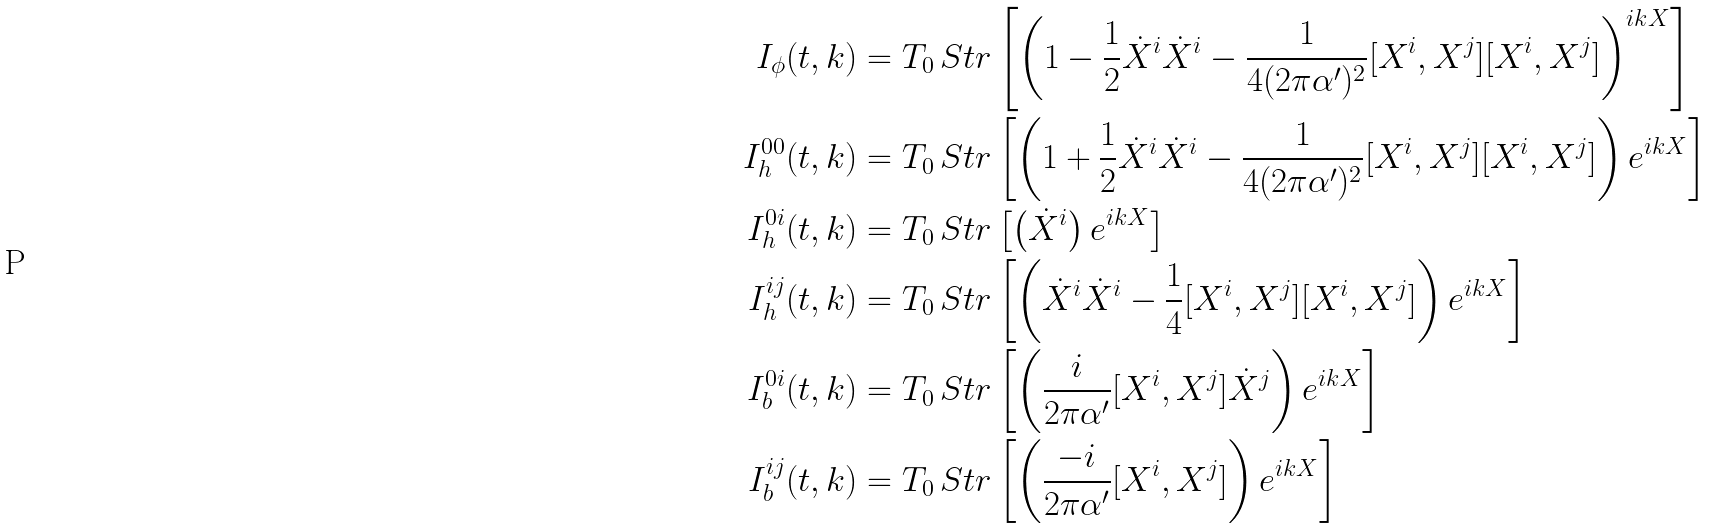<formula> <loc_0><loc_0><loc_500><loc_500>I _ { \phi } ( t , k ) & = T _ { 0 } \, S t r \left [ \left ( 1 - \frac { 1 } { 2 } \dot { X } ^ { i } \dot { X } ^ { i } - \frac { 1 } { 4 ( 2 \pi \alpha ^ { \prime } ) ^ { 2 } } [ X ^ { i } , X ^ { j } ] [ X ^ { i } , X ^ { j } ] \right ) ^ { i k X } \right ] \\ I _ { h } ^ { 0 0 } ( t , k ) & = T _ { 0 } \, S t r \left [ \left ( 1 + \frac { 1 } { 2 } \dot { X } ^ { i } \dot { X } ^ { i } - \frac { 1 } { 4 ( 2 \pi \alpha ^ { \prime } ) ^ { 2 } } [ X ^ { i } , X ^ { j } ] [ X ^ { i } , X ^ { j } ] \right ) e ^ { i k X } \right ] \\ I _ { h } ^ { 0 i } ( t , k ) & = T _ { 0 } \, S t r \left [ \left ( \dot { X } ^ { i } \right ) e ^ { i k X } \right ] \\ I _ { h } ^ { i j } ( t , k ) & = T _ { 0 } \, S t r \left [ \left ( \dot { X } ^ { i } \dot { X } ^ { i } - \frac { 1 } { 4 } [ X ^ { i } , X ^ { j } ] [ X ^ { i } , X ^ { j } ] \right ) e ^ { i k X } \right ] \\ I _ { b } ^ { 0 i } ( t , k ) & = T _ { 0 } \, S t r \left [ \left ( \frac { i } { 2 \pi \alpha ^ { \prime } } [ X ^ { i } , X ^ { j } ] \dot { X } ^ { j } \right ) e ^ { i k X } \right ] \\ I _ { b } ^ { i j } ( t , k ) & = T _ { 0 } \, S t r \left [ \left ( \frac { - i } { 2 \pi \alpha ^ { \prime } } [ X ^ { i } , X ^ { j } ] \right ) e ^ { i k X } \right ]</formula> 